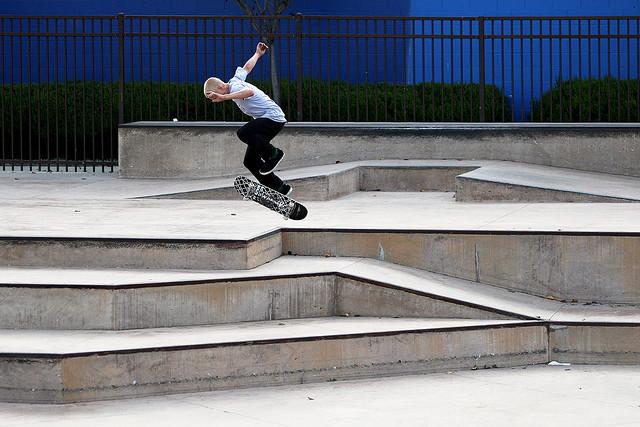Is it midday?
Concise answer only. Yes. Is he on a skateboard?
Quick response, please. Yes. Is the boy jumping?
Short answer required. Yes. 